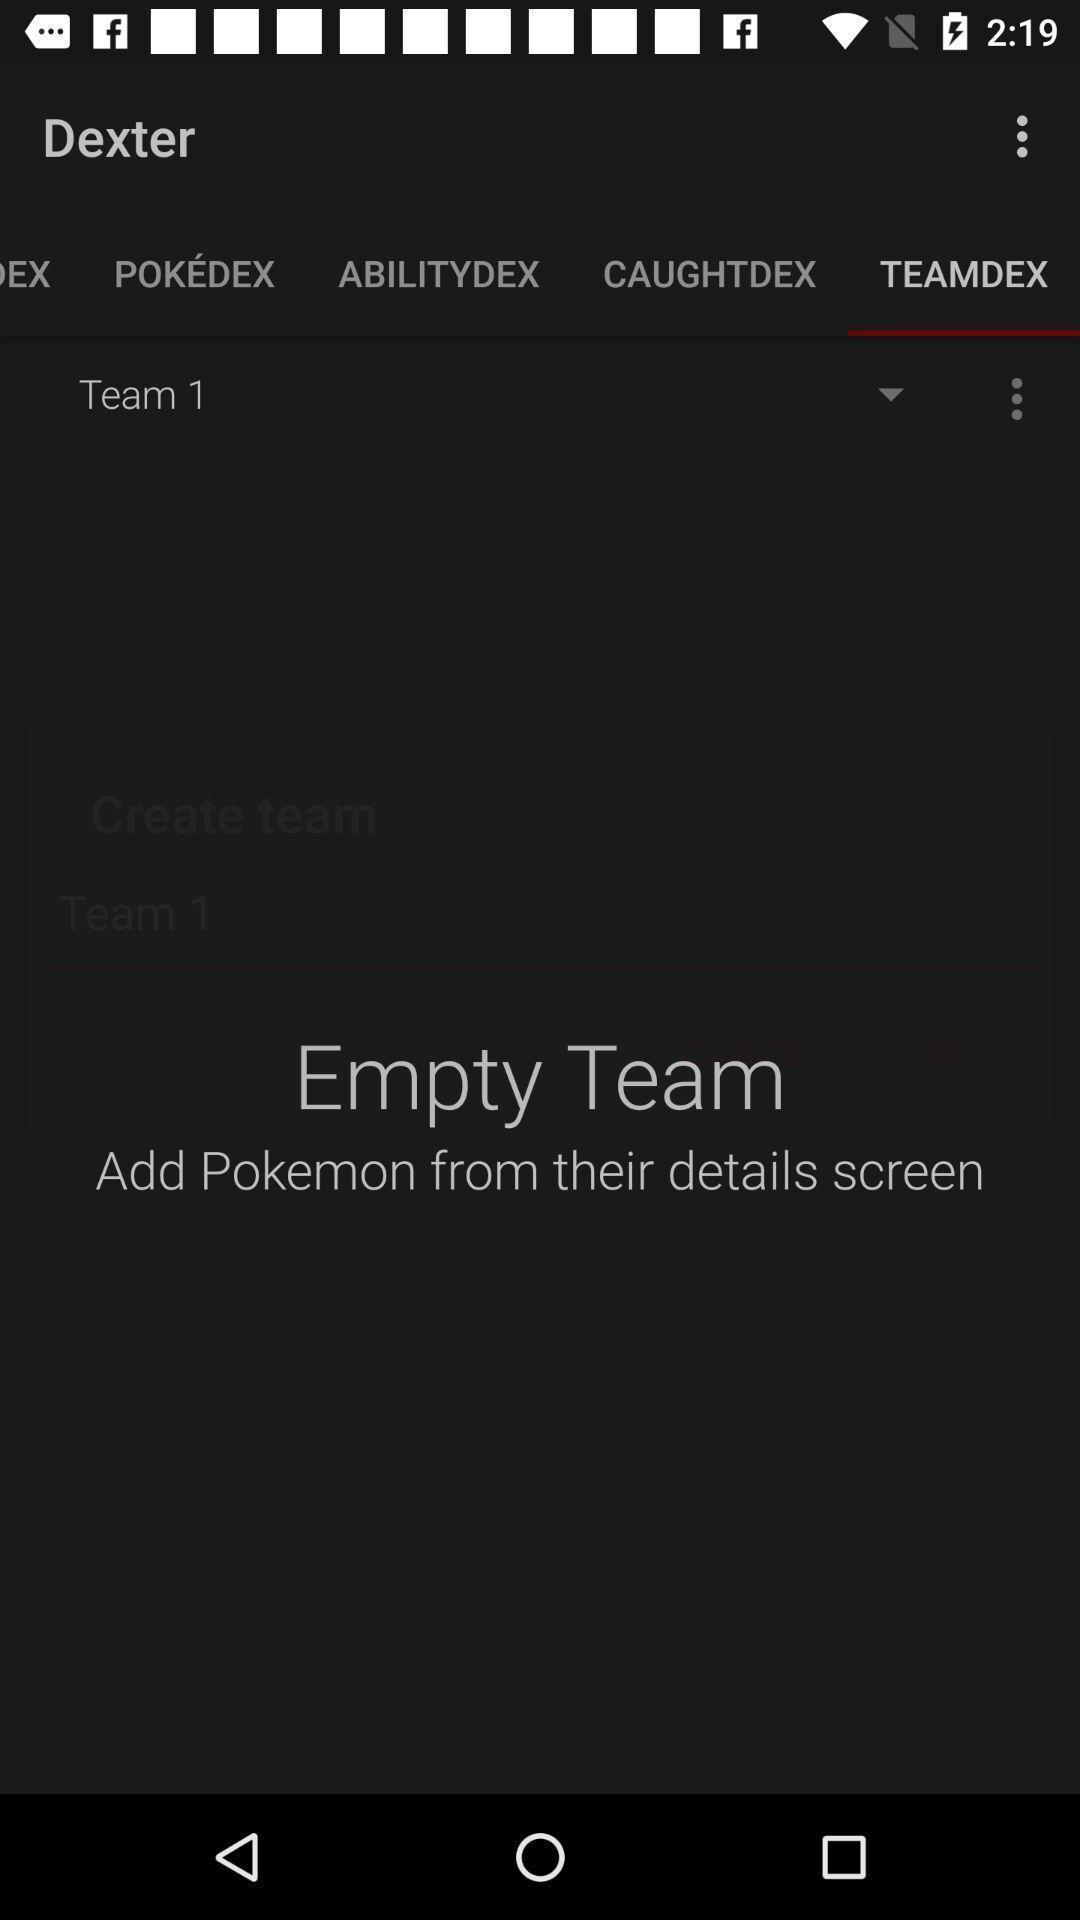Please provide a description for this image. Showing results for teamdex. 